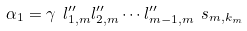<formula> <loc_0><loc_0><loc_500><loc_500>\alpha _ { 1 } = \gamma \ l _ { 1 , m } ^ { \prime \prime } l _ { 2 , m } ^ { \prime \prime } \cdots l _ { m - 1 , m } ^ { \prime \prime } \ s _ { m , k _ { m } }</formula> 